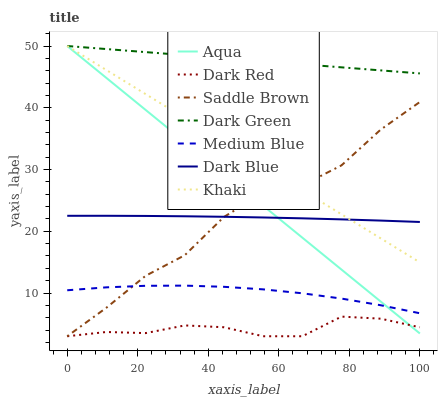Does Aqua have the minimum area under the curve?
Answer yes or no. No. Does Aqua have the maximum area under the curve?
Answer yes or no. No. Is Dark Red the smoothest?
Answer yes or no. No. Is Dark Red the roughest?
Answer yes or no. No. Does Aqua have the lowest value?
Answer yes or no. No. Does Dark Red have the highest value?
Answer yes or no. No. Is Medium Blue less than Dark Blue?
Answer yes or no. Yes. Is Dark Green greater than Dark Blue?
Answer yes or no. Yes. Does Medium Blue intersect Dark Blue?
Answer yes or no. No. 